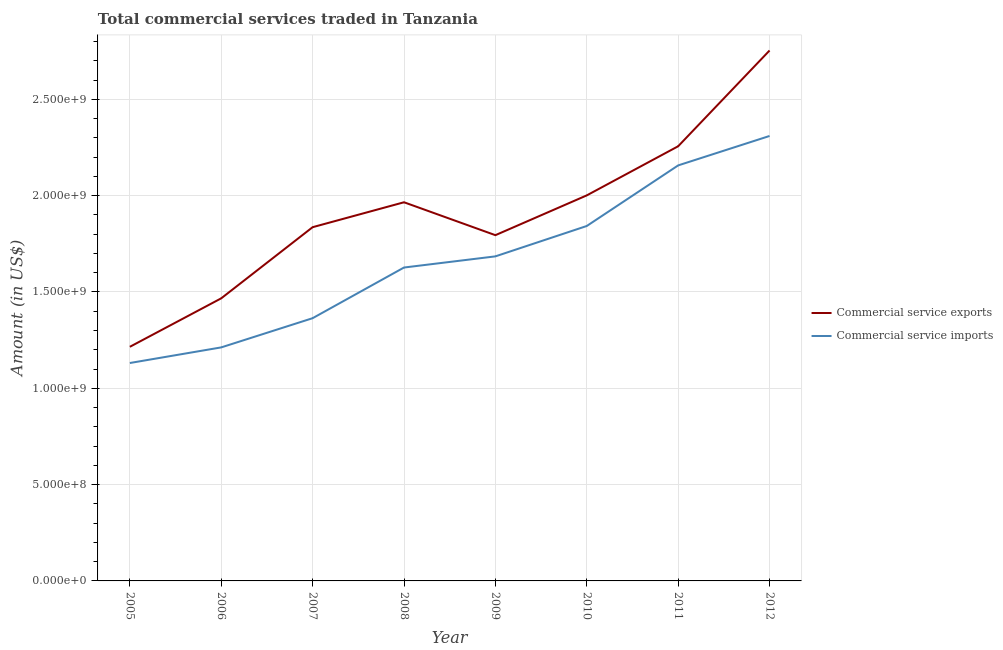Does the line corresponding to amount of commercial service exports intersect with the line corresponding to amount of commercial service imports?
Your answer should be compact. No. Is the number of lines equal to the number of legend labels?
Your answer should be compact. Yes. What is the amount of commercial service exports in 2009?
Provide a succinct answer. 1.79e+09. Across all years, what is the maximum amount of commercial service imports?
Offer a terse response. 2.31e+09. Across all years, what is the minimum amount of commercial service imports?
Offer a terse response. 1.13e+09. In which year was the amount of commercial service exports maximum?
Your answer should be very brief. 2012. In which year was the amount of commercial service imports minimum?
Your answer should be very brief. 2005. What is the total amount of commercial service imports in the graph?
Offer a terse response. 1.33e+1. What is the difference between the amount of commercial service imports in 2007 and that in 2009?
Ensure brevity in your answer.  -3.21e+08. What is the difference between the amount of commercial service imports in 2011 and the amount of commercial service exports in 2008?
Offer a very short reply. 1.91e+08. What is the average amount of commercial service imports per year?
Provide a short and direct response. 1.67e+09. In the year 2005, what is the difference between the amount of commercial service exports and amount of commercial service imports?
Keep it short and to the point. 8.41e+07. What is the ratio of the amount of commercial service imports in 2007 to that in 2012?
Keep it short and to the point. 0.59. What is the difference between the highest and the second highest amount of commercial service imports?
Give a very brief answer. 1.53e+08. What is the difference between the highest and the lowest amount of commercial service exports?
Provide a succinct answer. 1.54e+09. Is the amount of commercial service imports strictly less than the amount of commercial service exports over the years?
Offer a terse response. Yes. What is the difference between two consecutive major ticks on the Y-axis?
Provide a short and direct response. 5.00e+08. Are the values on the major ticks of Y-axis written in scientific E-notation?
Make the answer very short. Yes. What is the title of the graph?
Keep it short and to the point. Total commercial services traded in Tanzania. Does "Girls" appear as one of the legend labels in the graph?
Provide a succinct answer. No. What is the Amount (in US$) in Commercial service exports in 2005?
Your answer should be compact. 1.22e+09. What is the Amount (in US$) in Commercial service imports in 2005?
Ensure brevity in your answer.  1.13e+09. What is the Amount (in US$) in Commercial service exports in 2006?
Your answer should be compact. 1.47e+09. What is the Amount (in US$) of Commercial service imports in 2006?
Your answer should be compact. 1.21e+09. What is the Amount (in US$) in Commercial service exports in 2007?
Offer a very short reply. 1.84e+09. What is the Amount (in US$) of Commercial service imports in 2007?
Provide a succinct answer. 1.36e+09. What is the Amount (in US$) in Commercial service exports in 2008?
Your answer should be very brief. 1.97e+09. What is the Amount (in US$) in Commercial service imports in 2008?
Keep it short and to the point. 1.63e+09. What is the Amount (in US$) in Commercial service exports in 2009?
Offer a terse response. 1.79e+09. What is the Amount (in US$) in Commercial service imports in 2009?
Ensure brevity in your answer.  1.68e+09. What is the Amount (in US$) in Commercial service exports in 2010?
Offer a terse response. 2.00e+09. What is the Amount (in US$) in Commercial service imports in 2010?
Offer a terse response. 1.84e+09. What is the Amount (in US$) in Commercial service exports in 2011?
Offer a terse response. 2.26e+09. What is the Amount (in US$) of Commercial service imports in 2011?
Give a very brief answer. 2.16e+09. What is the Amount (in US$) in Commercial service exports in 2012?
Offer a terse response. 2.75e+09. What is the Amount (in US$) of Commercial service imports in 2012?
Give a very brief answer. 2.31e+09. Across all years, what is the maximum Amount (in US$) of Commercial service exports?
Keep it short and to the point. 2.75e+09. Across all years, what is the maximum Amount (in US$) of Commercial service imports?
Keep it short and to the point. 2.31e+09. Across all years, what is the minimum Amount (in US$) in Commercial service exports?
Your response must be concise. 1.22e+09. Across all years, what is the minimum Amount (in US$) of Commercial service imports?
Ensure brevity in your answer.  1.13e+09. What is the total Amount (in US$) of Commercial service exports in the graph?
Your response must be concise. 1.53e+1. What is the total Amount (in US$) of Commercial service imports in the graph?
Your response must be concise. 1.33e+1. What is the difference between the Amount (in US$) in Commercial service exports in 2005 and that in 2006?
Provide a short and direct response. -2.52e+08. What is the difference between the Amount (in US$) of Commercial service imports in 2005 and that in 2006?
Keep it short and to the point. -8.11e+07. What is the difference between the Amount (in US$) of Commercial service exports in 2005 and that in 2007?
Offer a terse response. -6.21e+08. What is the difference between the Amount (in US$) in Commercial service imports in 2005 and that in 2007?
Make the answer very short. -2.33e+08. What is the difference between the Amount (in US$) of Commercial service exports in 2005 and that in 2008?
Your answer should be very brief. -7.50e+08. What is the difference between the Amount (in US$) of Commercial service imports in 2005 and that in 2008?
Provide a succinct answer. -4.96e+08. What is the difference between the Amount (in US$) of Commercial service exports in 2005 and that in 2009?
Make the answer very short. -5.80e+08. What is the difference between the Amount (in US$) of Commercial service imports in 2005 and that in 2009?
Ensure brevity in your answer.  -5.54e+08. What is the difference between the Amount (in US$) of Commercial service exports in 2005 and that in 2010?
Provide a short and direct response. -7.86e+08. What is the difference between the Amount (in US$) of Commercial service imports in 2005 and that in 2010?
Your response must be concise. -7.11e+08. What is the difference between the Amount (in US$) of Commercial service exports in 2005 and that in 2011?
Provide a succinct answer. -1.04e+09. What is the difference between the Amount (in US$) in Commercial service imports in 2005 and that in 2011?
Ensure brevity in your answer.  -1.03e+09. What is the difference between the Amount (in US$) of Commercial service exports in 2005 and that in 2012?
Provide a succinct answer. -1.54e+09. What is the difference between the Amount (in US$) of Commercial service imports in 2005 and that in 2012?
Provide a succinct answer. -1.18e+09. What is the difference between the Amount (in US$) of Commercial service exports in 2006 and that in 2007?
Keep it short and to the point. -3.69e+08. What is the difference between the Amount (in US$) of Commercial service imports in 2006 and that in 2007?
Provide a short and direct response. -1.52e+08. What is the difference between the Amount (in US$) of Commercial service exports in 2006 and that in 2008?
Offer a very short reply. -4.99e+08. What is the difference between the Amount (in US$) of Commercial service imports in 2006 and that in 2008?
Provide a short and direct response. -4.15e+08. What is the difference between the Amount (in US$) in Commercial service exports in 2006 and that in 2009?
Your answer should be very brief. -3.28e+08. What is the difference between the Amount (in US$) in Commercial service imports in 2006 and that in 2009?
Give a very brief answer. -4.73e+08. What is the difference between the Amount (in US$) in Commercial service exports in 2006 and that in 2010?
Your answer should be compact. -5.34e+08. What is the difference between the Amount (in US$) in Commercial service imports in 2006 and that in 2010?
Provide a succinct answer. -6.30e+08. What is the difference between the Amount (in US$) in Commercial service exports in 2006 and that in 2011?
Keep it short and to the point. -7.89e+08. What is the difference between the Amount (in US$) in Commercial service imports in 2006 and that in 2011?
Give a very brief answer. -9.45e+08. What is the difference between the Amount (in US$) in Commercial service exports in 2006 and that in 2012?
Make the answer very short. -1.29e+09. What is the difference between the Amount (in US$) in Commercial service imports in 2006 and that in 2012?
Ensure brevity in your answer.  -1.10e+09. What is the difference between the Amount (in US$) in Commercial service exports in 2007 and that in 2008?
Provide a short and direct response. -1.29e+08. What is the difference between the Amount (in US$) in Commercial service imports in 2007 and that in 2008?
Make the answer very short. -2.63e+08. What is the difference between the Amount (in US$) in Commercial service exports in 2007 and that in 2009?
Provide a short and direct response. 4.15e+07. What is the difference between the Amount (in US$) of Commercial service imports in 2007 and that in 2009?
Provide a succinct answer. -3.21e+08. What is the difference between the Amount (in US$) of Commercial service exports in 2007 and that in 2010?
Provide a succinct answer. -1.65e+08. What is the difference between the Amount (in US$) of Commercial service imports in 2007 and that in 2010?
Ensure brevity in your answer.  -4.79e+08. What is the difference between the Amount (in US$) in Commercial service exports in 2007 and that in 2011?
Your answer should be very brief. -4.20e+08. What is the difference between the Amount (in US$) in Commercial service imports in 2007 and that in 2011?
Offer a very short reply. -7.93e+08. What is the difference between the Amount (in US$) of Commercial service exports in 2007 and that in 2012?
Make the answer very short. -9.17e+08. What is the difference between the Amount (in US$) in Commercial service imports in 2007 and that in 2012?
Make the answer very short. -9.46e+08. What is the difference between the Amount (in US$) in Commercial service exports in 2008 and that in 2009?
Keep it short and to the point. 1.71e+08. What is the difference between the Amount (in US$) in Commercial service imports in 2008 and that in 2009?
Keep it short and to the point. -5.79e+07. What is the difference between the Amount (in US$) in Commercial service exports in 2008 and that in 2010?
Your answer should be compact. -3.58e+07. What is the difference between the Amount (in US$) of Commercial service imports in 2008 and that in 2010?
Give a very brief answer. -2.16e+08. What is the difference between the Amount (in US$) of Commercial service exports in 2008 and that in 2011?
Give a very brief answer. -2.91e+08. What is the difference between the Amount (in US$) of Commercial service imports in 2008 and that in 2011?
Offer a terse response. -5.30e+08. What is the difference between the Amount (in US$) in Commercial service exports in 2008 and that in 2012?
Give a very brief answer. -7.88e+08. What is the difference between the Amount (in US$) in Commercial service imports in 2008 and that in 2012?
Give a very brief answer. -6.83e+08. What is the difference between the Amount (in US$) of Commercial service exports in 2009 and that in 2010?
Offer a terse response. -2.07e+08. What is the difference between the Amount (in US$) in Commercial service imports in 2009 and that in 2010?
Provide a short and direct response. -1.58e+08. What is the difference between the Amount (in US$) of Commercial service exports in 2009 and that in 2011?
Offer a terse response. -4.62e+08. What is the difference between the Amount (in US$) of Commercial service imports in 2009 and that in 2011?
Your response must be concise. -4.72e+08. What is the difference between the Amount (in US$) in Commercial service exports in 2009 and that in 2012?
Your response must be concise. -9.59e+08. What is the difference between the Amount (in US$) in Commercial service imports in 2009 and that in 2012?
Your answer should be very brief. -6.25e+08. What is the difference between the Amount (in US$) of Commercial service exports in 2010 and that in 2011?
Your answer should be very brief. -2.55e+08. What is the difference between the Amount (in US$) of Commercial service imports in 2010 and that in 2011?
Your response must be concise. -3.15e+08. What is the difference between the Amount (in US$) in Commercial service exports in 2010 and that in 2012?
Your response must be concise. -7.52e+08. What is the difference between the Amount (in US$) in Commercial service imports in 2010 and that in 2012?
Provide a succinct answer. -4.67e+08. What is the difference between the Amount (in US$) of Commercial service exports in 2011 and that in 2012?
Offer a very short reply. -4.97e+08. What is the difference between the Amount (in US$) in Commercial service imports in 2011 and that in 2012?
Offer a very short reply. -1.53e+08. What is the difference between the Amount (in US$) of Commercial service exports in 2005 and the Amount (in US$) of Commercial service imports in 2006?
Make the answer very short. 3.00e+06. What is the difference between the Amount (in US$) in Commercial service exports in 2005 and the Amount (in US$) in Commercial service imports in 2007?
Give a very brief answer. -1.49e+08. What is the difference between the Amount (in US$) of Commercial service exports in 2005 and the Amount (in US$) of Commercial service imports in 2008?
Your answer should be very brief. -4.12e+08. What is the difference between the Amount (in US$) of Commercial service exports in 2005 and the Amount (in US$) of Commercial service imports in 2009?
Ensure brevity in your answer.  -4.70e+08. What is the difference between the Amount (in US$) of Commercial service exports in 2005 and the Amount (in US$) of Commercial service imports in 2010?
Your answer should be very brief. -6.27e+08. What is the difference between the Amount (in US$) in Commercial service exports in 2005 and the Amount (in US$) in Commercial service imports in 2011?
Provide a succinct answer. -9.42e+08. What is the difference between the Amount (in US$) of Commercial service exports in 2005 and the Amount (in US$) of Commercial service imports in 2012?
Your response must be concise. -1.09e+09. What is the difference between the Amount (in US$) in Commercial service exports in 2006 and the Amount (in US$) in Commercial service imports in 2007?
Keep it short and to the point. 1.03e+08. What is the difference between the Amount (in US$) of Commercial service exports in 2006 and the Amount (in US$) of Commercial service imports in 2008?
Provide a short and direct response. -1.60e+08. What is the difference between the Amount (in US$) of Commercial service exports in 2006 and the Amount (in US$) of Commercial service imports in 2009?
Make the answer very short. -2.18e+08. What is the difference between the Amount (in US$) in Commercial service exports in 2006 and the Amount (in US$) in Commercial service imports in 2010?
Provide a succinct answer. -3.76e+08. What is the difference between the Amount (in US$) in Commercial service exports in 2006 and the Amount (in US$) in Commercial service imports in 2011?
Keep it short and to the point. -6.90e+08. What is the difference between the Amount (in US$) in Commercial service exports in 2006 and the Amount (in US$) in Commercial service imports in 2012?
Ensure brevity in your answer.  -8.43e+08. What is the difference between the Amount (in US$) in Commercial service exports in 2007 and the Amount (in US$) in Commercial service imports in 2008?
Provide a succinct answer. 2.09e+08. What is the difference between the Amount (in US$) of Commercial service exports in 2007 and the Amount (in US$) of Commercial service imports in 2009?
Make the answer very short. 1.51e+08. What is the difference between the Amount (in US$) of Commercial service exports in 2007 and the Amount (in US$) of Commercial service imports in 2010?
Your response must be concise. -6.25e+06. What is the difference between the Amount (in US$) in Commercial service exports in 2007 and the Amount (in US$) in Commercial service imports in 2011?
Offer a terse response. -3.21e+08. What is the difference between the Amount (in US$) of Commercial service exports in 2007 and the Amount (in US$) of Commercial service imports in 2012?
Your response must be concise. -4.73e+08. What is the difference between the Amount (in US$) in Commercial service exports in 2008 and the Amount (in US$) in Commercial service imports in 2009?
Offer a very short reply. 2.81e+08. What is the difference between the Amount (in US$) in Commercial service exports in 2008 and the Amount (in US$) in Commercial service imports in 2010?
Provide a succinct answer. 1.23e+08. What is the difference between the Amount (in US$) in Commercial service exports in 2008 and the Amount (in US$) in Commercial service imports in 2011?
Give a very brief answer. -1.91e+08. What is the difference between the Amount (in US$) of Commercial service exports in 2008 and the Amount (in US$) of Commercial service imports in 2012?
Your answer should be very brief. -3.44e+08. What is the difference between the Amount (in US$) of Commercial service exports in 2009 and the Amount (in US$) of Commercial service imports in 2010?
Offer a terse response. -4.77e+07. What is the difference between the Amount (in US$) of Commercial service exports in 2009 and the Amount (in US$) of Commercial service imports in 2011?
Provide a succinct answer. -3.62e+08. What is the difference between the Amount (in US$) in Commercial service exports in 2009 and the Amount (in US$) in Commercial service imports in 2012?
Provide a short and direct response. -5.15e+08. What is the difference between the Amount (in US$) of Commercial service exports in 2010 and the Amount (in US$) of Commercial service imports in 2011?
Your answer should be very brief. -1.56e+08. What is the difference between the Amount (in US$) in Commercial service exports in 2010 and the Amount (in US$) in Commercial service imports in 2012?
Offer a terse response. -3.08e+08. What is the difference between the Amount (in US$) in Commercial service exports in 2011 and the Amount (in US$) in Commercial service imports in 2012?
Your response must be concise. -5.34e+07. What is the average Amount (in US$) of Commercial service exports per year?
Your answer should be very brief. 1.91e+09. What is the average Amount (in US$) of Commercial service imports per year?
Offer a terse response. 1.67e+09. In the year 2005, what is the difference between the Amount (in US$) in Commercial service exports and Amount (in US$) in Commercial service imports?
Offer a very short reply. 8.41e+07. In the year 2006, what is the difference between the Amount (in US$) of Commercial service exports and Amount (in US$) of Commercial service imports?
Provide a short and direct response. 2.55e+08. In the year 2007, what is the difference between the Amount (in US$) in Commercial service exports and Amount (in US$) in Commercial service imports?
Your answer should be compact. 4.72e+08. In the year 2008, what is the difference between the Amount (in US$) in Commercial service exports and Amount (in US$) in Commercial service imports?
Keep it short and to the point. 3.39e+08. In the year 2009, what is the difference between the Amount (in US$) of Commercial service exports and Amount (in US$) of Commercial service imports?
Offer a terse response. 1.10e+08. In the year 2010, what is the difference between the Amount (in US$) of Commercial service exports and Amount (in US$) of Commercial service imports?
Your answer should be very brief. 1.59e+08. In the year 2011, what is the difference between the Amount (in US$) of Commercial service exports and Amount (in US$) of Commercial service imports?
Offer a very short reply. 9.93e+07. In the year 2012, what is the difference between the Amount (in US$) in Commercial service exports and Amount (in US$) in Commercial service imports?
Make the answer very short. 4.44e+08. What is the ratio of the Amount (in US$) of Commercial service exports in 2005 to that in 2006?
Your answer should be compact. 0.83. What is the ratio of the Amount (in US$) in Commercial service imports in 2005 to that in 2006?
Ensure brevity in your answer.  0.93. What is the ratio of the Amount (in US$) of Commercial service exports in 2005 to that in 2007?
Provide a succinct answer. 0.66. What is the ratio of the Amount (in US$) of Commercial service imports in 2005 to that in 2007?
Provide a succinct answer. 0.83. What is the ratio of the Amount (in US$) in Commercial service exports in 2005 to that in 2008?
Offer a terse response. 0.62. What is the ratio of the Amount (in US$) of Commercial service imports in 2005 to that in 2008?
Make the answer very short. 0.7. What is the ratio of the Amount (in US$) of Commercial service exports in 2005 to that in 2009?
Offer a terse response. 0.68. What is the ratio of the Amount (in US$) of Commercial service imports in 2005 to that in 2009?
Ensure brevity in your answer.  0.67. What is the ratio of the Amount (in US$) in Commercial service exports in 2005 to that in 2010?
Your answer should be very brief. 0.61. What is the ratio of the Amount (in US$) in Commercial service imports in 2005 to that in 2010?
Give a very brief answer. 0.61. What is the ratio of the Amount (in US$) of Commercial service exports in 2005 to that in 2011?
Your response must be concise. 0.54. What is the ratio of the Amount (in US$) in Commercial service imports in 2005 to that in 2011?
Make the answer very short. 0.52. What is the ratio of the Amount (in US$) of Commercial service exports in 2005 to that in 2012?
Your response must be concise. 0.44. What is the ratio of the Amount (in US$) in Commercial service imports in 2005 to that in 2012?
Offer a very short reply. 0.49. What is the ratio of the Amount (in US$) in Commercial service exports in 2006 to that in 2007?
Provide a succinct answer. 0.8. What is the ratio of the Amount (in US$) in Commercial service imports in 2006 to that in 2007?
Your response must be concise. 0.89. What is the ratio of the Amount (in US$) in Commercial service exports in 2006 to that in 2008?
Provide a short and direct response. 0.75. What is the ratio of the Amount (in US$) of Commercial service imports in 2006 to that in 2008?
Offer a very short reply. 0.75. What is the ratio of the Amount (in US$) of Commercial service exports in 2006 to that in 2009?
Keep it short and to the point. 0.82. What is the ratio of the Amount (in US$) in Commercial service imports in 2006 to that in 2009?
Provide a short and direct response. 0.72. What is the ratio of the Amount (in US$) in Commercial service exports in 2006 to that in 2010?
Offer a very short reply. 0.73. What is the ratio of the Amount (in US$) of Commercial service imports in 2006 to that in 2010?
Provide a succinct answer. 0.66. What is the ratio of the Amount (in US$) of Commercial service exports in 2006 to that in 2011?
Provide a succinct answer. 0.65. What is the ratio of the Amount (in US$) of Commercial service imports in 2006 to that in 2011?
Offer a very short reply. 0.56. What is the ratio of the Amount (in US$) of Commercial service exports in 2006 to that in 2012?
Provide a short and direct response. 0.53. What is the ratio of the Amount (in US$) in Commercial service imports in 2006 to that in 2012?
Keep it short and to the point. 0.52. What is the ratio of the Amount (in US$) in Commercial service exports in 2007 to that in 2008?
Offer a terse response. 0.93. What is the ratio of the Amount (in US$) of Commercial service imports in 2007 to that in 2008?
Provide a succinct answer. 0.84. What is the ratio of the Amount (in US$) in Commercial service exports in 2007 to that in 2009?
Ensure brevity in your answer.  1.02. What is the ratio of the Amount (in US$) in Commercial service imports in 2007 to that in 2009?
Make the answer very short. 0.81. What is the ratio of the Amount (in US$) in Commercial service exports in 2007 to that in 2010?
Ensure brevity in your answer.  0.92. What is the ratio of the Amount (in US$) of Commercial service imports in 2007 to that in 2010?
Your answer should be compact. 0.74. What is the ratio of the Amount (in US$) in Commercial service exports in 2007 to that in 2011?
Your answer should be very brief. 0.81. What is the ratio of the Amount (in US$) in Commercial service imports in 2007 to that in 2011?
Give a very brief answer. 0.63. What is the ratio of the Amount (in US$) of Commercial service exports in 2007 to that in 2012?
Offer a terse response. 0.67. What is the ratio of the Amount (in US$) in Commercial service imports in 2007 to that in 2012?
Provide a short and direct response. 0.59. What is the ratio of the Amount (in US$) of Commercial service exports in 2008 to that in 2009?
Your answer should be compact. 1.1. What is the ratio of the Amount (in US$) in Commercial service imports in 2008 to that in 2009?
Offer a terse response. 0.97. What is the ratio of the Amount (in US$) in Commercial service exports in 2008 to that in 2010?
Offer a terse response. 0.98. What is the ratio of the Amount (in US$) in Commercial service imports in 2008 to that in 2010?
Your answer should be very brief. 0.88. What is the ratio of the Amount (in US$) of Commercial service exports in 2008 to that in 2011?
Your response must be concise. 0.87. What is the ratio of the Amount (in US$) of Commercial service imports in 2008 to that in 2011?
Offer a terse response. 0.75. What is the ratio of the Amount (in US$) of Commercial service exports in 2008 to that in 2012?
Offer a very short reply. 0.71. What is the ratio of the Amount (in US$) of Commercial service imports in 2008 to that in 2012?
Keep it short and to the point. 0.7. What is the ratio of the Amount (in US$) of Commercial service exports in 2009 to that in 2010?
Offer a very short reply. 0.9. What is the ratio of the Amount (in US$) of Commercial service imports in 2009 to that in 2010?
Make the answer very short. 0.91. What is the ratio of the Amount (in US$) of Commercial service exports in 2009 to that in 2011?
Ensure brevity in your answer.  0.8. What is the ratio of the Amount (in US$) in Commercial service imports in 2009 to that in 2011?
Your answer should be compact. 0.78. What is the ratio of the Amount (in US$) in Commercial service exports in 2009 to that in 2012?
Keep it short and to the point. 0.65. What is the ratio of the Amount (in US$) in Commercial service imports in 2009 to that in 2012?
Make the answer very short. 0.73. What is the ratio of the Amount (in US$) in Commercial service exports in 2010 to that in 2011?
Offer a very short reply. 0.89. What is the ratio of the Amount (in US$) in Commercial service imports in 2010 to that in 2011?
Make the answer very short. 0.85. What is the ratio of the Amount (in US$) of Commercial service exports in 2010 to that in 2012?
Your answer should be very brief. 0.73. What is the ratio of the Amount (in US$) of Commercial service imports in 2010 to that in 2012?
Ensure brevity in your answer.  0.8. What is the ratio of the Amount (in US$) in Commercial service exports in 2011 to that in 2012?
Offer a terse response. 0.82. What is the ratio of the Amount (in US$) in Commercial service imports in 2011 to that in 2012?
Your answer should be very brief. 0.93. What is the difference between the highest and the second highest Amount (in US$) of Commercial service exports?
Provide a succinct answer. 4.97e+08. What is the difference between the highest and the second highest Amount (in US$) in Commercial service imports?
Offer a terse response. 1.53e+08. What is the difference between the highest and the lowest Amount (in US$) in Commercial service exports?
Your response must be concise. 1.54e+09. What is the difference between the highest and the lowest Amount (in US$) in Commercial service imports?
Your answer should be compact. 1.18e+09. 